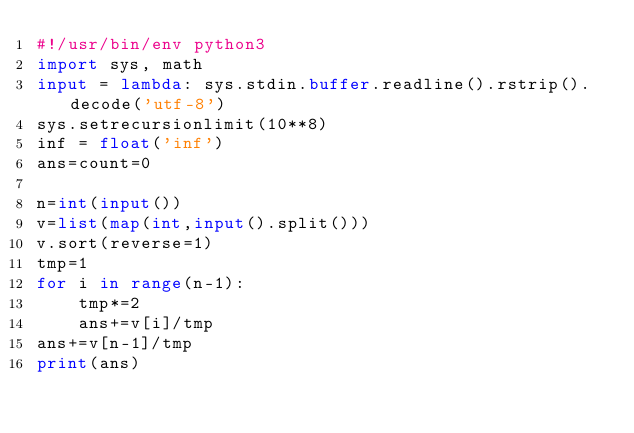Convert code to text. <code><loc_0><loc_0><loc_500><loc_500><_Python_>#!/usr/bin/env python3
import sys, math
input = lambda: sys.stdin.buffer.readline().rstrip().decode('utf-8')
sys.setrecursionlimit(10**8)
inf = float('inf')
ans=count=0

n=int(input())
v=list(map(int,input().split()))
v.sort(reverse=1)
tmp=1
for i in range(n-1):
    tmp*=2
    ans+=v[i]/tmp
ans+=v[n-1]/tmp
print(ans)
</code> 